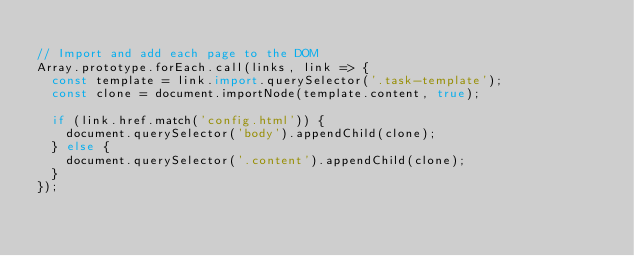Convert code to text. <code><loc_0><loc_0><loc_500><loc_500><_JavaScript_>
// Import and add each page to the DOM
Array.prototype.forEach.call(links, link => {
  const template = link.import.querySelector('.task-template');
  const clone = document.importNode(template.content, true);

  if (link.href.match('config.html')) {
    document.querySelector('body').appendChild(clone);
  } else {
    document.querySelector('.content').appendChild(clone);
  }
});
</code> 